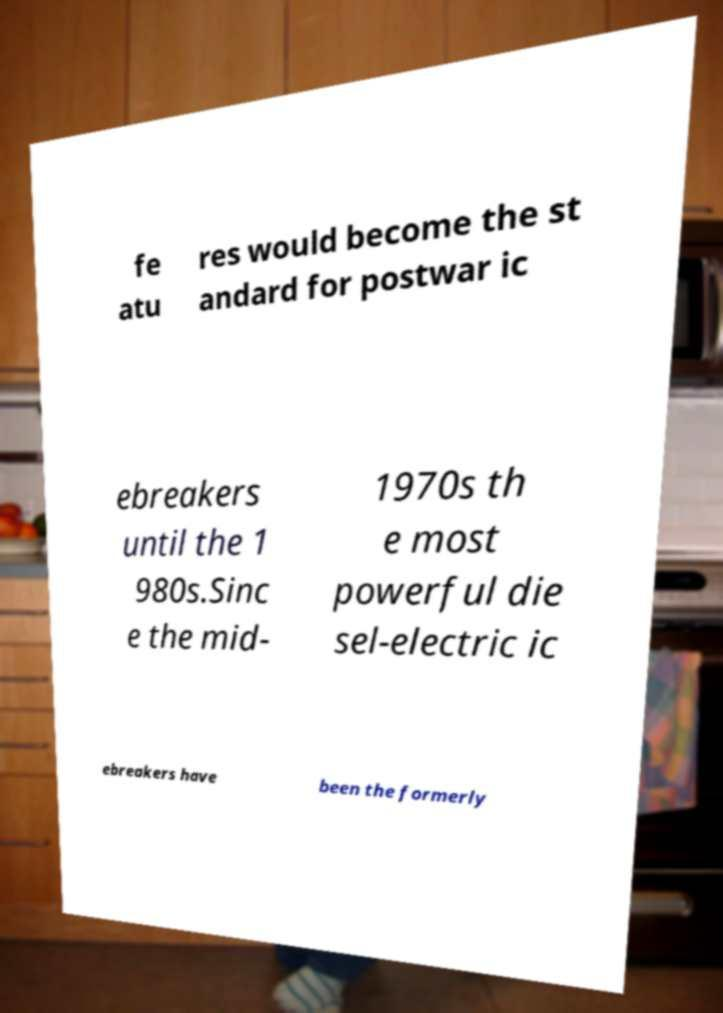There's text embedded in this image that I need extracted. Can you transcribe it verbatim? fe atu res would become the st andard for postwar ic ebreakers until the 1 980s.Sinc e the mid- 1970s th e most powerful die sel-electric ic ebreakers have been the formerly 